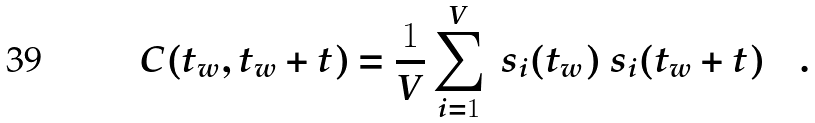<formula> <loc_0><loc_0><loc_500><loc_500>C ( t _ { w } , t _ { w } + t ) = \frac { 1 } { V } \sum _ { i = 1 } ^ { V } \ s _ { i } ( t _ { w } ) \ s _ { i } ( t _ { w } + t ) \quad .</formula> 